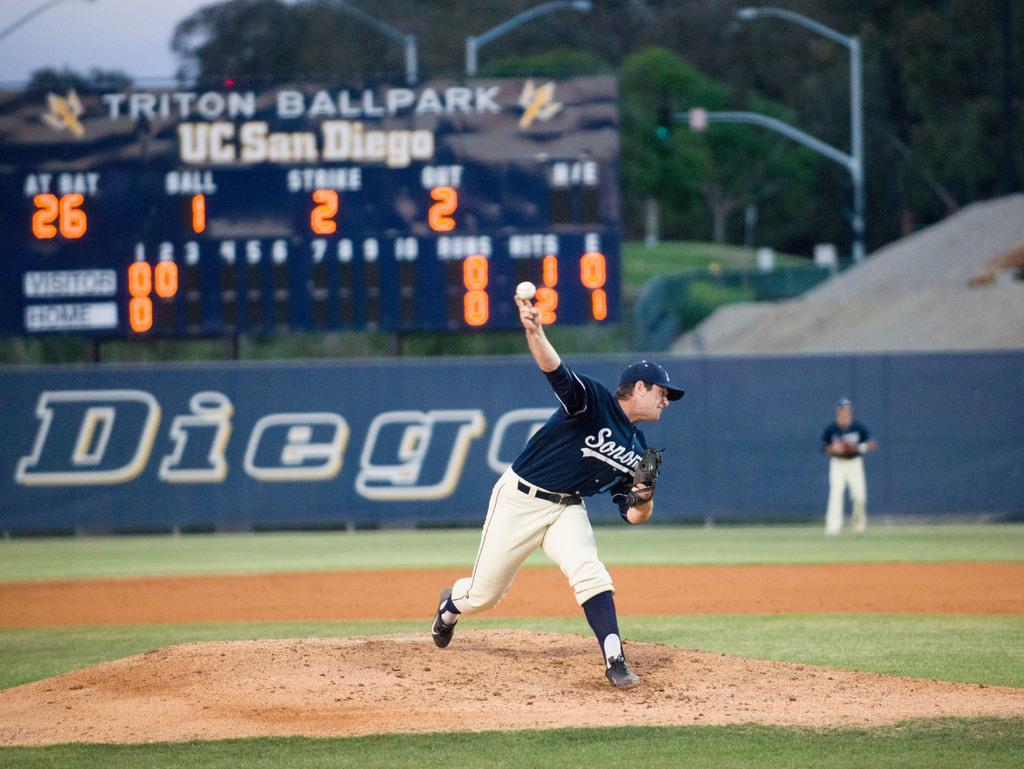<image>
Write a terse but informative summary of the picture. A baseball player is in the process of pitching a ball with the diego logo in the back wall. 